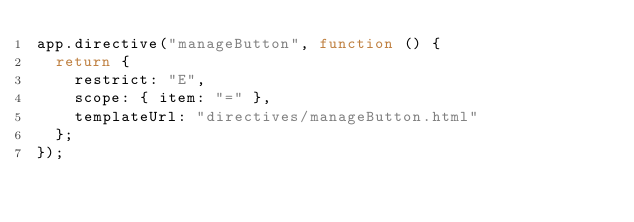<code> <loc_0><loc_0><loc_500><loc_500><_JavaScript_>app.directive("manageButton", function () {
	return {
		restrict: "E",
		scope: { item: "=" },
		templateUrl: "directives/manageButton.html"
	};
});
</code> 